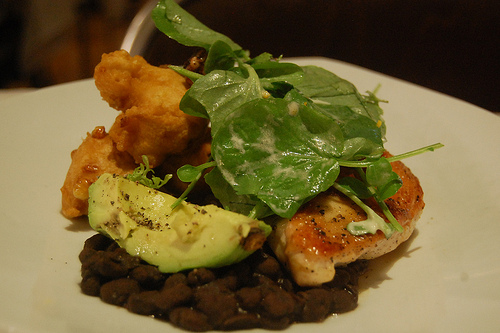<image>
Is there a chicken behind the lime? Yes. From this viewpoint, the chicken is positioned behind the lime, with the lime partially or fully occluding the chicken. 